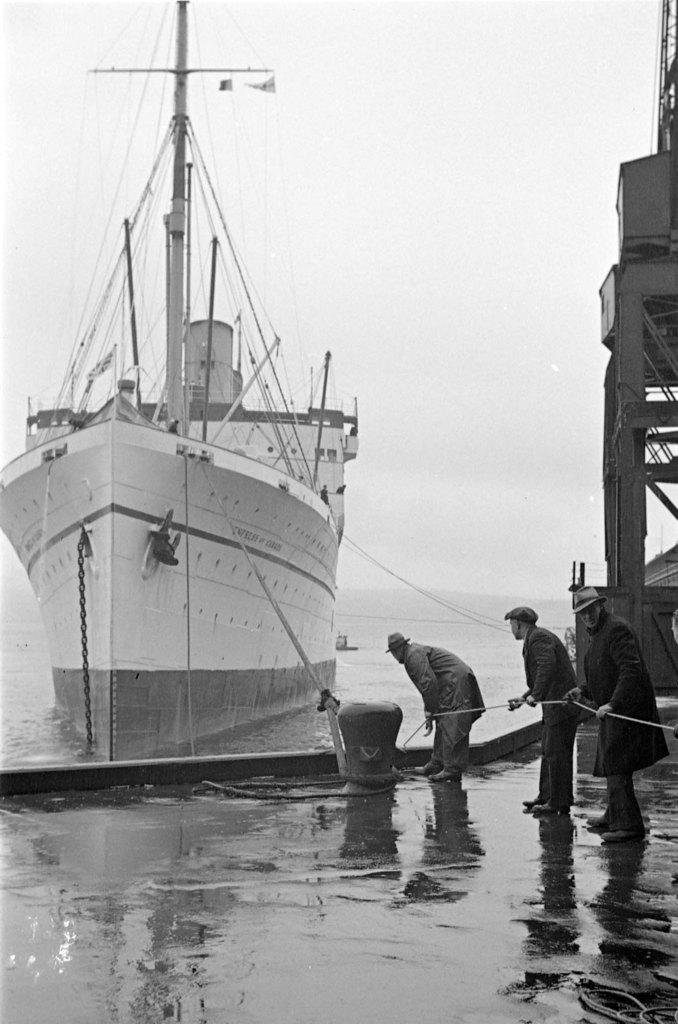What is the main subject of the image? The main subject of the image is a ship. Where is the ship located in the image? The ship is on the water. What are the people in the image doing? The people standing on the harbor are holding a rope. How is the rope connected to the ship? The rope is connected to the ship. What type of selection process is being conducted by the letters in the image? There are no letters present in the image, so no selection process can be observed. 